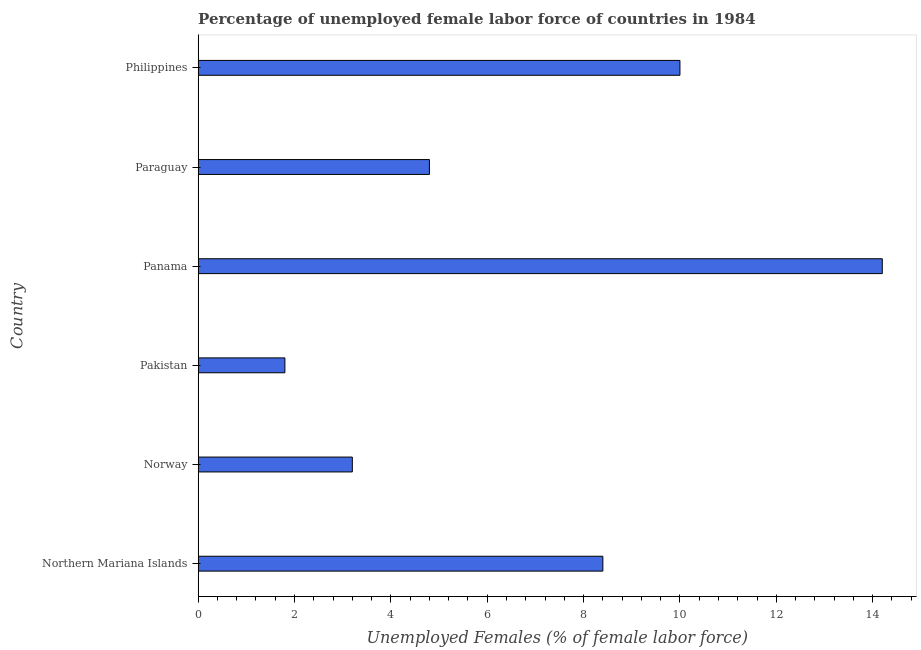Does the graph contain any zero values?
Provide a succinct answer. No. What is the title of the graph?
Offer a terse response. Percentage of unemployed female labor force of countries in 1984. What is the label or title of the X-axis?
Provide a succinct answer. Unemployed Females (% of female labor force). What is the label or title of the Y-axis?
Ensure brevity in your answer.  Country. What is the total unemployed female labour force in Northern Mariana Islands?
Offer a very short reply. 8.4. Across all countries, what is the maximum total unemployed female labour force?
Your answer should be compact. 14.2. Across all countries, what is the minimum total unemployed female labour force?
Offer a very short reply. 1.8. In which country was the total unemployed female labour force maximum?
Provide a succinct answer. Panama. What is the sum of the total unemployed female labour force?
Give a very brief answer. 42.4. What is the difference between the total unemployed female labour force in Norway and Panama?
Keep it short and to the point. -11. What is the average total unemployed female labour force per country?
Provide a succinct answer. 7.07. What is the median total unemployed female labour force?
Your answer should be compact. 6.6. What is the ratio of the total unemployed female labour force in Norway to that in Pakistan?
Ensure brevity in your answer.  1.78. Is the difference between the total unemployed female labour force in Paraguay and Philippines greater than the difference between any two countries?
Keep it short and to the point. No. What is the difference between the highest and the second highest total unemployed female labour force?
Provide a succinct answer. 4.2. What is the difference between the highest and the lowest total unemployed female labour force?
Offer a terse response. 12.4. In how many countries, is the total unemployed female labour force greater than the average total unemployed female labour force taken over all countries?
Provide a short and direct response. 3. What is the difference between two consecutive major ticks on the X-axis?
Give a very brief answer. 2. Are the values on the major ticks of X-axis written in scientific E-notation?
Provide a succinct answer. No. What is the Unemployed Females (% of female labor force) of Northern Mariana Islands?
Your answer should be compact. 8.4. What is the Unemployed Females (% of female labor force) in Norway?
Your response must be concise. 3.2. What is the Unemployed Females (% of female labor force) in Pakistan?
Make the answer very short. 1.8. What is the Unemployed Females (% of female labor force) in Panama?
Your answer should be compact. 14.2. What is the Unemployed Females (% of female labor force) in Paraguay?
Keep it short and to the point. 4.8. What is the difference between the Unemployed Females (% of female labor force) in Northern Mariana Islands and Pakistan?
Provide a succinct answer. 6.6. What is the difference between the Unemployed Females (% of female labor force) in Northern Mariana Islands and Panama?
Your answer should be very brief. -5.8. What is the difference between the Unemployed Females (% of female labor force) in Northern Mariana Islands and Paraguay?
Your answer should be very brief. 3.6. What is the difference between the Unemployed Females (% of female labor force) in Northern Mariana Islands and Philippines?
Your answer should be compact. -1.6. What is the difference between the Unemployed Females (% of female labor force) in Norway and Paraguay?
Keep it short and to the point. -1.6. What is the difference between the Unemployed Females (% of female labor force) in Norway and Philippines?
Ensure brevity in your answer.  -6.8. What is the difference between the Unemployed Females (% of female labor force) in Pakistan and Paraguay?
Your answer should be compact. -3. What is the difference between the Unemployed Females (% of female labor force) in Pakistan and Philippines?
Ensure brevity in your answer.  -8.2. What is the ratio of the Unemployed Females (% of female labor force) in Northern Mariana Islands to that in Norway?
Keep it short and to the point. 2.62. What is the ratio of the Unemployed Females (% of female labor force) in Northern Mariana Islands to that in Pakistan?
Make the answer very short. 4.67. What is the ratio of the Unemployed Females (% of female labor force) in Northern Mariana Islands to that in Panama?
Provide a succinct answer. 0.59. What is the ratio of the Unemployed Females (% of female labor force) in Northern Mariana Islands to that in Paraguay?
Keep it short and to the point. 1.75. What is the ratio of the Unemployed Females (% of female labor force) in Northern Mariana Islands to that in Philippines?
Offer a very short reply. 0.84. What is the ratio of the Unemployed Females (% of female labor force) in Norway to that in Pakistan?
Ensure brevity in your answer.  1.78. What is the ratio of the Unemployed Females (% of female labor force) in Norway to that in Panama?
Give a very brief answer. 0.23. What is the ratio of the Unemployed Females (% of female labor force) in Norway to that in Paraguay?
Your answer should be compact. 0.67. What is the ratio of the Unemployed Females (% of female labor force) in Norway to that in Philippines?
Your answer should be very brief. 0.32. What is the ratio of the Unemployed Females (% of female labor force) in Pakistan to that in Panama?
Provide a short and direct response. 0.13. What is the ratio of the Unemployed Females (% of female labor force) in Pakistan to that in Paraguay?
Provide a short and direct response. 0.38. What is the ratio of the Unemployed Females (% of female labor force) in Pakistan to that in Philippines?
Your answer should be very brief. 0.18. What is the ratio of the Unemployed Females (% of female labor force) in Panama to that in Paraguay?
Your answer should be compact. 2.96. What is the ratio of the Unemployed Females (% of female labor force) in Panama to that in Philippines?
Your answer should be very brief. 1.42. What is the ratio of the Unemployed Females (% of female labor force) in Paraguay to that in Philippines?
Offer a terse response. 0.48. 